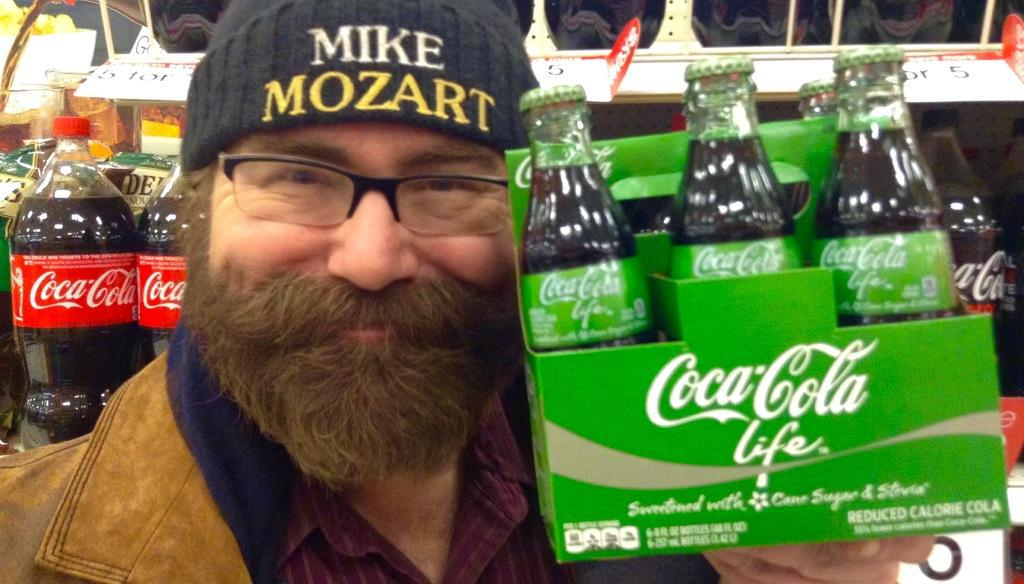What is the main subject of the image? The main subject of the image is a man. Can you describe the man's appearance? The man is wearing a hat and is smiling. What is the man holding in the image? The man is holding coca cola bottles. What can be seen in the background of the image? There is a bottles rack and papers in the background of the image. What type of celery is being used as a prop in the image? There is no celery present in the image. What kind of art can be seen hanging on the wall in the image? There is no art visible on the wall in the image. 